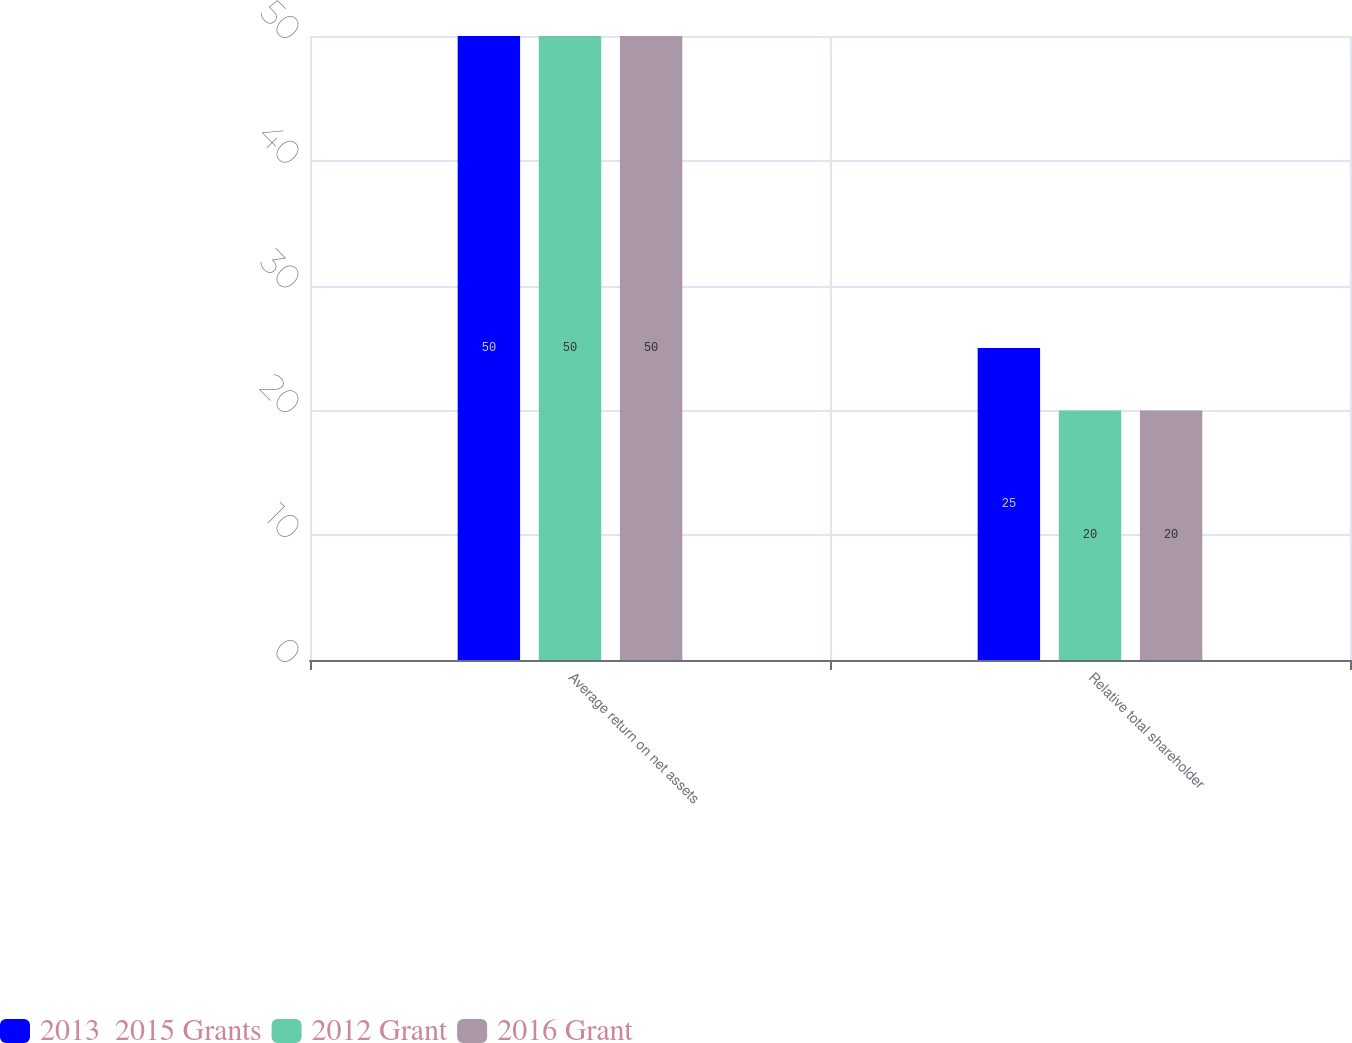Convert chart to OTSL. <chart><loc_0><loc_0><loc_500><loc_500><stacked_bar_chart><ecel><fcel>Average return on net assets<fcel>Relative total shareholder<nl><fcel>2013  2015 Grants<fcel>50<fcel>25<nl><fcel>2012 Grant<fcel>50<fcel>20<nl><fcel>2016 Grant<fcel>50<fcel>20<nl></chart> 